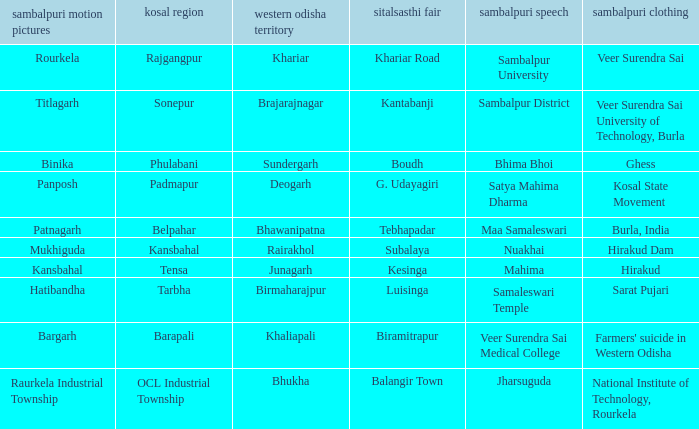What is the kosal with hatibandha as the sambalpuri cinema? Tarbha. 